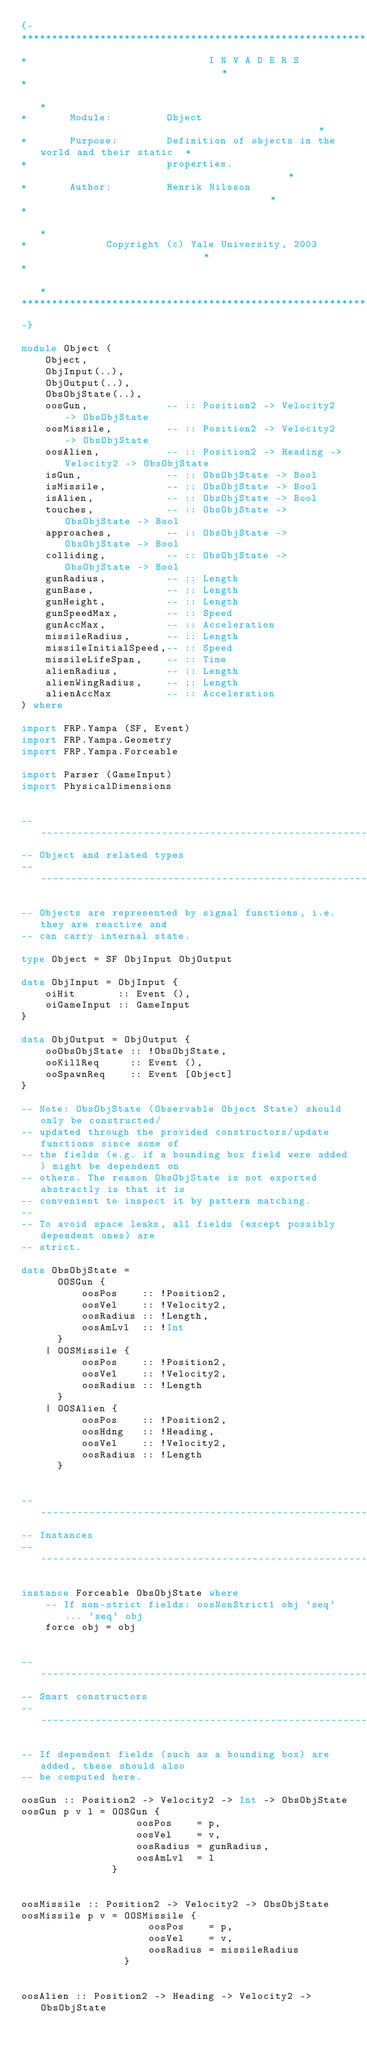<code> <loc_0><loc_0><loc_500><loc_500><_Haskell_>{-
******************************************************************************
*                              I N V A D E R S                               *
*                                                                            *
*       Module:         Object                                               *
*       Purpose:        Definition of objects in the world and their static  *
*                       properties.                                          *
*       Author:         Henrik Nilsson                                       *
*                                                                            *
*             Copyright (c) Yale University, 2003                            *
*                                                                            *
******************************************************************************
-}

module Object (
    Object,
    ObjInput(..),
    ObjOutput(..),
    ObsObjState(..),
    oosGun,             -- :: Position2 -> Velocity2 -> ObsObjState
    oosMissile,         -- :: Position2 -> Velocity2 -> ObsObjState
    oosAlien,           -- :: Position2 -> Heading -> Velocity2 -> ObsObjState
    isGun,              -- :: ObsObjState -> Bool
    isMissile,          -- :: ObsObjState -> Bool
    isAlien,            -- :: ObsObjState -> Bool
    touches,            -- :: ObsObjState -> ObsObjState -> Bool
    approaches,         -- :: ObsObjState -> ObsObjState -> Bool
    colliding,          -- :: ObsObjState -> ObsObjState -> Bool
    gunRadius,          -- :: Length
    gunBase,            -- :: Length
    gunHeight,          -- :: Length
    gunSpeedMax,        -- :: Speed
    gunAccMax,          -- :: Acceleration
    missileRadius,      -- :: Length
    missileInitialSpeed,-- :: Speed
    missileLifeSpan,    -- :: Time
    alienRadius,        -- :: Length
    alienWingRadius,    -- :: Length
    alienAccMax         -- :: Acceleration
) where

import FRP.Yampa (SF, Event)
import FRP.Yampa.Geometry
import FRP.Yampa.Forceable

import Parser (GameInput)
import PhysicalDimensions


------------------------------------------------------------------------------
-- Object and related types
------------------------------------------------------------------------------

-- Objects are represented by signal functions, i.e. they are reactive and
-- can carry internal state.

type Object = SF ObjInput ObjOutput

data ObjInput = ObjInput {
    oiHit       :: Event (),
    oiGameInput :: GameInput
}

data ObjOutput = ObjOutput {
    ooObsObjState :: !ObsObjState,
    ooKillReq     :: Event (),
    ooSpawnReq    :: Event [Object]
}

-- Note: ObsObjState (Observable Object State) should only be constructed/
-- updated through the provided constructors/update functions since some of
-- the fields (e.g. if a bounding box field were added) might be dependent on
-- others. The reason ObsObjState is not exported abstractly is that it is
-- convenient to inspect it by pattern matching.
-- 
-- To avoid space leaks, all fields (except possibly dependent ones) are
-- strict.

data ObsObjState =
      OOSGun {
          oosPos    :: !Position2,
          oosVel    :: !Velocity2,
          oosRadius :: !Length,
          oosAmLvl  :: !Int
      }
    | OOSMissile {
          oosPos    :: !Position2,
          oosVel    :: !Velocity2,
          oosRadius :: !Length
      }
    | OOSAlien {
          oosPos    :: !Position2,
          oosHdng   :: !Heading,
          oosVel    :: !Velocity2,
          oosRadius :: !Length
      }


------------------------------------------------------------------------------
-- Instances
------------------------------------------------------------------------------

instance Forceable ObsObjState where
    -- If non-strict fields: oosNonStrict1 obj `seq` ... `seq` obj 
    force obj = obj


------------------------------------------------------------------------------
-- Smart constructors
------------------------------------------------------------------------------

-- If dependent fields (such as a bounding box) are added, these should also
-- be computed here.

oosGun :: Position2 -> Velocity2 -> Int -> ObsObjState
oosGun p v l = OOSGun {
                   oosPos    = p,
                   oosVel    = v,
                   oosRadius = gunRadius,
                   oosAmLvl  = l
               }


oosMissile :: Position2 -> Velocity2 -> ObsObjState
oosMissile p v = OOSMissile {
                     oosPos    = p,
                     oosVel    = v,
                     oosRadius = missileRadius
                 }


oosAlien :: Position2 -> Heading -> Velocity2 -> ObsObjState</code> 